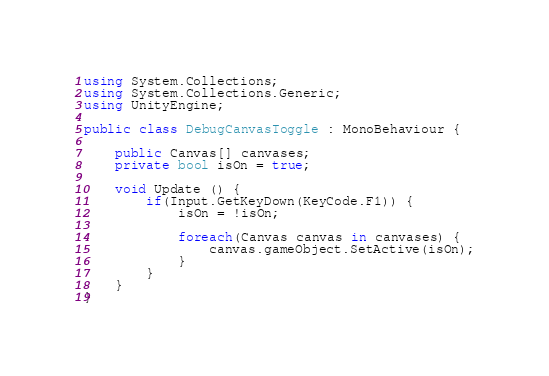<code> <loc_0><loc_0><loc_500><loc_500><_C#_>using System.Collections;
using System.Collections.Generic;
using UnityEngine;

public class DebugCanvasToggle : MonoBehaviour {

    public Canvas[] canvases;
    private bool isOn = true;

    void Update () {
        if(Input.GetKeyDown(KeyCode.F1)) {
            isOn = !isOn;

            foreach(Canvas canvas in canvases) {
                canvas.gameObject.SetActive(isOn);
            }
        }
    }
}
</code> 